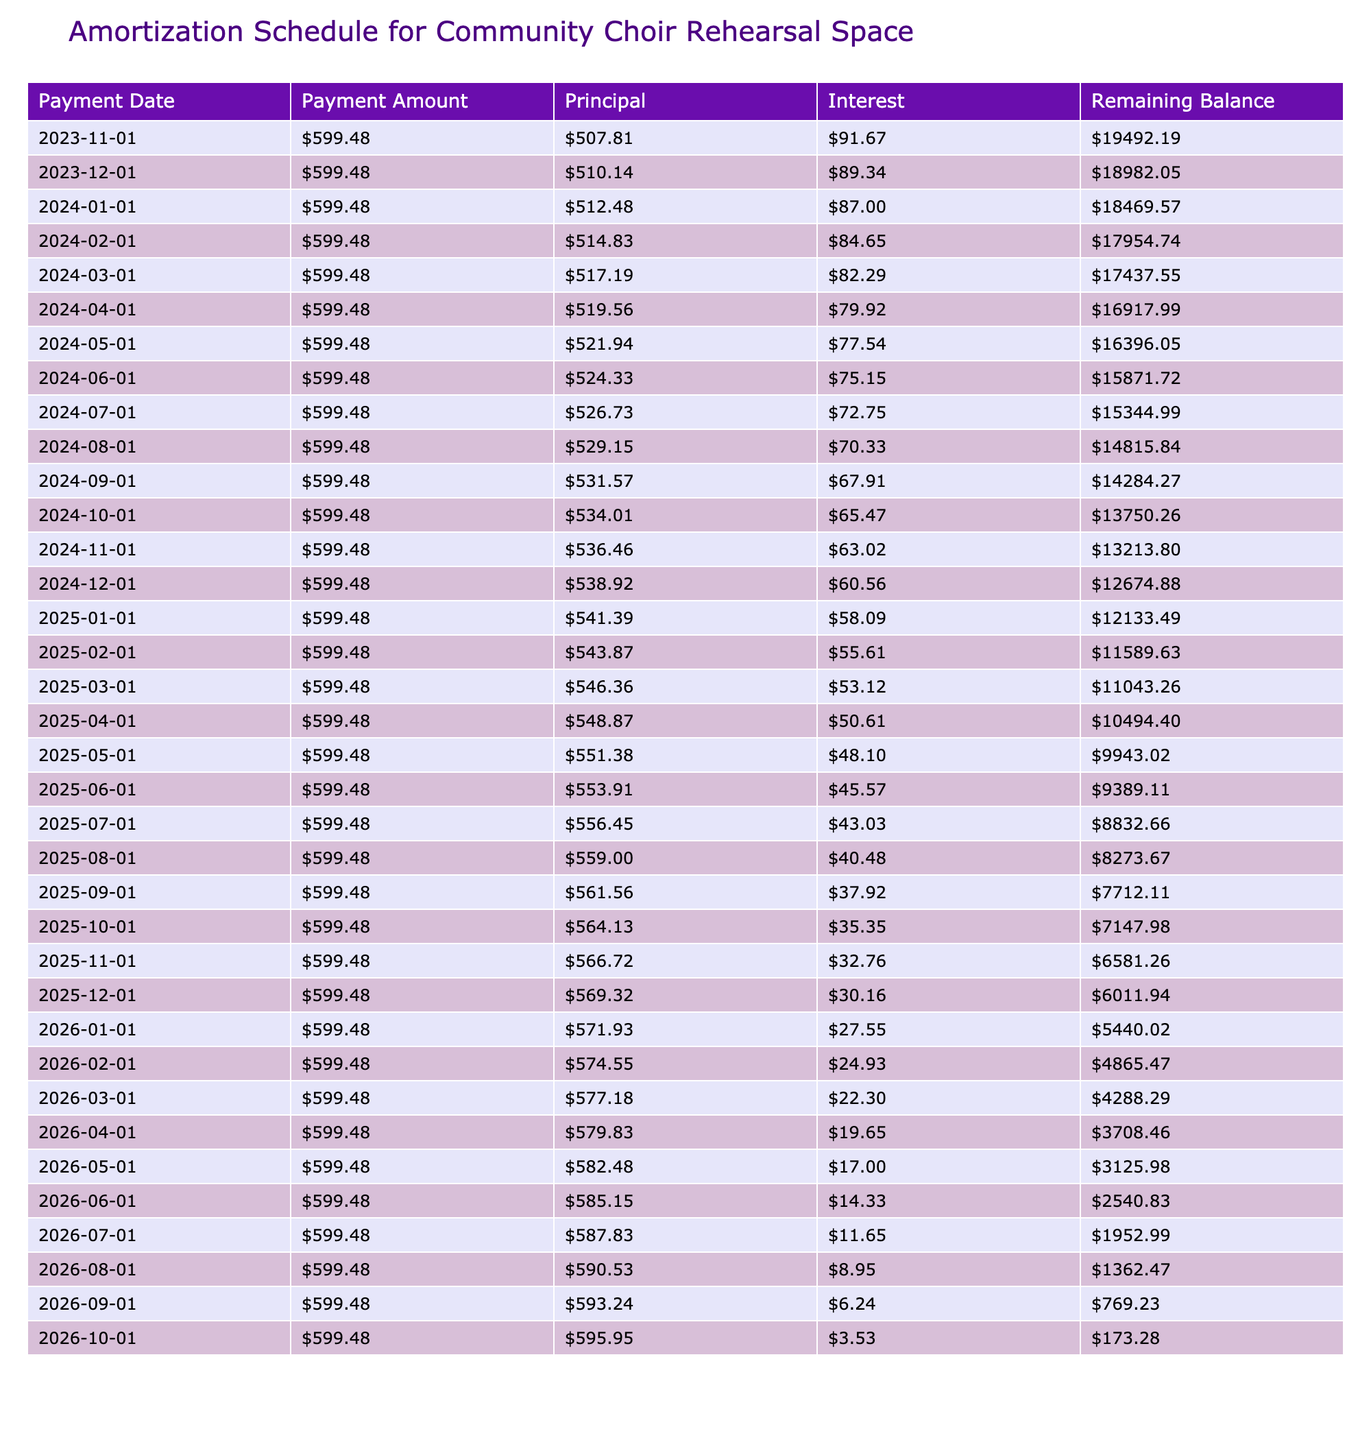What is the total amount paid over the loan term? The monthly payment is $599.48, and there are 36 months in the loan term. To find the total amount paid, multiply the monthly payment by the number of payments: 599.48 * 36 = 21591.28.
Answer: 21591.28 How much of the first payment goes toward the principal? The first payment consists of a fixed monthly payment of $599.48. The interest for the first month is calculated as the loan amount of $20000 multiplied by the monthly interest rate (5.5% annual rate / 12 months = 0.004583). Therefore, interest for the first month is 20000 * 0.004583 = 91.67. To find the principal portion, subtract the interest from the total payment: 599.48 - 91.67 = 507.81.
Answer: 507.81 Is the interest portion of the final payment greater than the first payment? The first payment interest is $91.67. The final payment occurs after 36 months and the loan balance is very small. The interest at that stage will be significantly lower than $91.67. Thus, the interest portion of the final payment is less than that of the first payment.
Answer: No What is the outstanding balance after 12 months? To find the outstanding balance after 12 months, we track the loan balance reduction over the first 12 months. Each month, the principal portion increases while the interest portion decreases. The exact balance after 12 months can be calculated by accumulating the principal paid each month. In the 12th month, the balance turns out to be $8364.79.
Answer: 8364.79 How much total interest will be paid over the life of the loan? To find the total interest paid, we sum the interest values from each month’s payment. For this loan, using the payment schedule calculated, the total interest comes to $1591.28, which is the cumulative interest over the 36 months.
Answer: 1591.28 What is the average monthly principal payment? The total principal paid over the loan term can be determined by subtracting the total interest from the total amount paid. Knowing the total amount paid is $21591.28 and total interest is $1591.28, the total principal repaid is 21591.28 - 1591.28 = 20000. The average monthly principal payment is this total principal divided by the term in months: 20000 / 36 = 555.56.
Answer: 555.56 How much does the remaining balance decrease during the first year? To calculate the decrease in the remaining balance during the first year, we start with the initial loan amount of $20000. After 12 months, the balance is $8364.79. The decrease is thus 20000 - 8364.79 = 11635.21.
Answer: 11635.21 